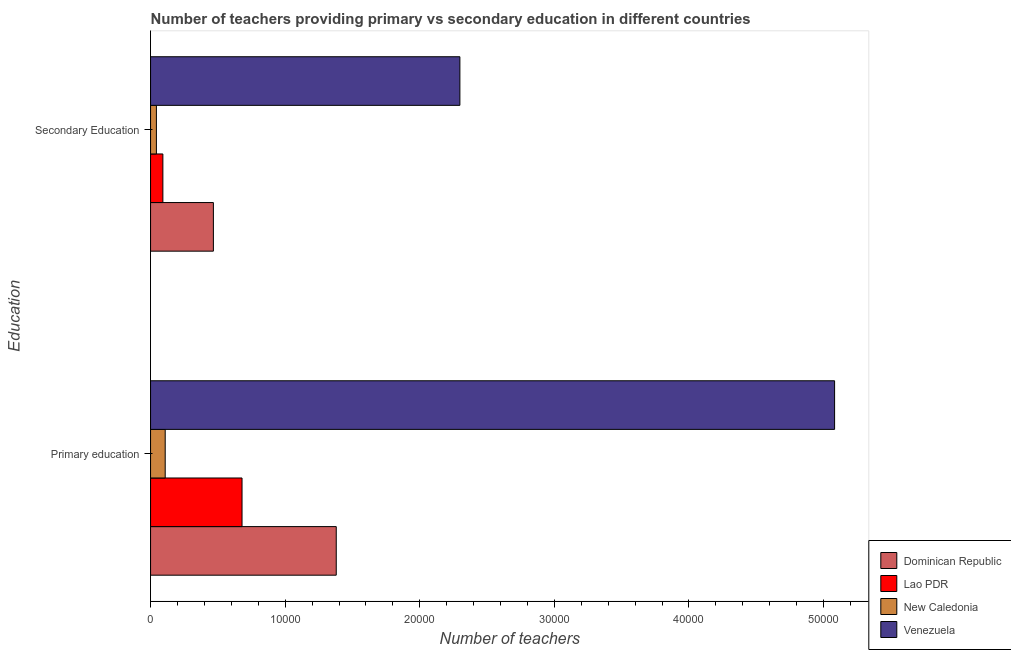Are the number of bars per tick equal to the number of legend labels?
Give a very brief answer. Yes. How many bars are there on the 1st tick from the top?
Offer a terse response. 4. What is the number of primary teachers in Venezuela?
Make the answer very short. 5.08e+04. Across all countries, what is the maximum number of primary teachers?
Offer a very short reply. 5.08e+04. Across all countries, what is the minimum number of primary teachers?
Keep it short and to the point. 1087. In which country was the number of primary teachers maximum?
Offer a very short reply. Venezuela. In which country was the number of secondary teachers minimum?
Offer a terse response. New Caledonia. What is the total number of primary teachers in the graph?
Your response must be concise. 7.25e+04. What is the difference between the number of primary teachers in Venezuela and that in New Caledonia?
Give a very brief answer. 4.97e+04. What is the difference between the number of primary teachers in New Caledonia and the number of secondary teachers in Venezuela?
Provide a short and direct response. -2.19e+04. What is the average number of primary teachers per country?
Your response must be concise. 1.81e+04. What is the difference between the number of primary teachers and number of secondary teachers in Venezuela?
Give a very brief answer. 2.78e+04. In how many countries, is the number of secondary teachers greater than 24000 ?
Ensure brevity in your answer.  0. What is the ratio of the number of secondary teachers in Venezuela to that in New Caledonia?
Keep it short and to the point. 52.96. Is the number of primary teachers in Dominican Republic less than that in Lao PDR?
Your response must be concise. No. In how many countries, is the number of primary teachers greater than the average number of primary teachers taken over all countries?
Your response must be concise. 1. What does the 3rd bar from the top in Primary education represents?
Give a very brief answer. Lao PDR. What does the 3rd bar from the bottom in Primary education represents?
Provide a short and direct response. New Caledonia. How many bars are there?
Your answer should be very brief. 8. What is the difference between two consecutive major ticks on the X-axis?
Ensure brevity in your answer.  10000. Does the graph contain grids?
Keep it short and to the point. No. Where does the legend appear in the graph?
Provide a succinct answer. Bottom right. How many legend labels are there?
Offer a terse response. 4. What is the title of the graph?
Provide a short and direct response. Number of teachers providing primary vs secondary education in different countries. Does "Macedonia" appear as one of the legend labels in the graph?
Offer a terse response. No. What is the label or title of the X-axis?
Make the answer very short. Number of teachers. What is the label or title of the Y-axis?
Provide a succinct answer. Education. What is the Number of teachers of Dominican Republic in Primary education?
Offer a terse response. 1.38e+04. What is the Number of teachers of Lao PDR in Primary education?
Give a very brief answer. 6796. What is the Number of teachers in New Caledonia in Primary education?
Your answer should be compact. 1087. What is the Number of teachers of Venezuela in Primary education?
Keep it short and to the point. 5.08e+04. What is the Number of teachers in Dominican Republic in Secondary Education?
Your answer should be compact. 4668. What is the Number of teachers of Lao PDR in Secondary Education?
Make the answer very short. 915. What is the Number of teachers of New Caledonia in Secondary Education?
Offer a very short reply. 434. What is the Number of teachers in Venezuela in Secondary Education?
Make the answer very short. 2.30e+04. Across all Education, what is the maximum Number of teachers of Dominican Republic?
Offer a very short reply. 1.38e+04. Across all Education, what is the maximum Number of teachers in Lao PDR?
Ensure brevity in your answer.  6796. Across all Education, what is the maximum Number of teachers of New Caledonia?
Provide a short and direct response. 1087. Across all Education, what is the maximum Number of teachers of Venezuela?
Your answer should be very brief. 5.08e+04. Across all Education, what is the minimum Number of teachers of Dominican Republic?
Your response must be concise. 4668. Across all Education, what is the minimum Number of teachers in Lao PDR?
Ensure brevity in your answer.  915. Across all Education, what is the minimum Number of teachers of New Caledonia?
Make the answer very short. 434. Across all Education, what is the minimum Number of teachers in Venezuela?
Offer a terse response. 2.30e+04. What is the total Number of teachers of Dominican Republic in the graph?
Keep it short and to the point. 1.85e+04. What is the total Number of teachers in Lao PDR in the graph?
Your answer should be compact. 7711. What is the total Number of teachers of New Caledonia in the graph?
Ensure brevity in your answer.  1521. What is the total Number of teachers in Venezuela in the graph?
Make the answer very short. 7.38e+04. What is the difference between the Number of teachers of Dominican Republic in Primary education and that in Secondary Education?
Offer a terse response. 9128. What is the difference between the Number of teachers in Lao PDR in Primary education and that in Secondary Education?
Provide a short and direct response. 5881. What is the difference between the Number of teachers of New Caledonia in Primary education and that in Secondary Education?
Make the answer very short. 653. What is the difference between the Number of teachers of Venezuela in Primary education and that in Secondary Education?
Your answer should be compact. 2.78e+04. What is the difference between the Number of teachers in Dominican Republic in Primary education and the Number of teachers in Lao PDR in Secondary Education?
Ensure brevity in your answer.  1.29e+04. What is the difference between the Number of teachers of Dominican Republic in Primary education and the Number of teachers of New Caledonia in Secondary Education?
Your response must be concise. 1.34e+04. What is the difference between the Number of teachers in Dominican Republic in Primary education and the Number of teachers in Venezuela in Secondary Education?
Provide a short and direct response. -9187. What is the difference between the Number of teachers in Lao PDR in Primary education and the Number of teachers in New Caledonia in Secondary Education?
Give a very brief answer. 6362. What is the difference between the Number of teachers of Lao PDR in Primary education and the Number of teachers of Venezuela in Secondary Education?
Your answer should be compact. -1.62e+04. What is the difference between the Number of teachers in New Caledonia in Primary education and the Number of teachers in Venezuela in Secondary Education?
Your answer should be very brief. -2.19e+04. What is the average Number of teachers of Dominican Republic per Education?
Provide a succinct answer. 9232. What is the average Number of teachers in Lao PDR per Education?
Make the answer very short. 3855.5. What is the average Number of teachers of New Caledonia per Education?
Give a very brief answer. 760.5. What is the average Number of teachers in Venezuela per Education?
Give a very brief answer. 3.69e+04. What is the difference between the Number of teachers in Dominican Republic and Number of teachers in Lao PDR in Primary education?
Ensure brevity in your answer.  7000. What is the difference between the Number of teachers in Dominican Republic and Number of teachers in New Caledonia in Primary education?
Offer a terse response. 1.27e+04. What is the difference between the Number of teachers of Dominican Republic and Number of teachers of Venezuela in Primary education?
Provide a succinct answer. -3.70e+04. What is the difference between the Number of teachers in Lao PDR and Number of teachers in New Caledonia in Primary education?
Keep it short and to the point. 5709. What is the difference between the Number of teachers of Lao PDR and Number of teachers of Venezuela in Primary education?
Your answer should be compact. -4.40e+04. What is the difference between the Number of teachers of New Caledonia and Number of teachers of Venezuela in Primary education?
Make the answer very short. -4.97e+04. What is the difference between the Number of teachers in Dominican Republic and Number of teachers in Lao PDR in Secondary Education?
Provide a short and direct response. 3753. What is the difference between the Number of teachers of Dominican Republic and Number of teachers of New Caledonia in Secondary Education?
Keep it short and to the point. 4234. What is the difference between the Number of teachers in Dominican Republic and Number of teachers in Venezuela in Secondary Education?
Your response must be concise. -1.83e+04. What is the difference between the Number of teachers of Lao PDR and Number of teachers of New Caledonia in Secondary Education?
Your answer should be compact. 481. What is the difference between the Number of teachers in Lao PDR and Number of teachers in Venezuela in Secondary Education?
Offer a very short reply. -2.21e+04. What is the difference between the Number of teachers in New Caledonia and Number of teachers in Venezuela in Secondary Education?
Your answer should be compact. -2.25e+04. What is the ratio of the Number of teachers in Dominican Republic in Primary education to that in Secondary Education?
Offer a terse response. 2.96. What is the ratio of the Number of teachers in Lao PDR in Primary education to that in Secondary Education?
Offer a very short reply. 7.43. What is the ratio of the Number of teachers in New Caledonia in Primary education to that in Secondary Education?
Keep it short and to the point. 2.5. What is the ratio of the Number of teachers in Venezuela in Primary education to that in Secondary Education?
Offer a very short reply. 2.21. What is the difference between the highest and the second highest Number of teachers in Dominican Republic?
Your response must be concise. 9128. What is the difference between the highest and the second highest Number of teachers in Lao PDR?
Make the answer very short. 5881. What is the difference between the highest and the second highest Number of teachers in New Caledonia?
Offer a very short reply. 653. What is the difference between the highest and the second highest Number of teachers in Venezuela?
Keep it short and to the point. 2.78e+04. What is the difference between the highest and the lowest Number of teachers in Dominican Republic?
Keep it short and to the point. 9128. What is the difference between the highest and the lowest Number of teachers in Lao PDR?
Keep it short and to the point. 5881. What is the difference between the highest and the lowest Number of teachers in New Caledonia?
Offer a terse response. 653. What is the difference between the highest and the lowest Number of teachers of Venezuela?
Provide a succinct answer. 2.78e+04. 